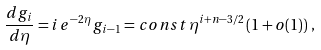Convert formula to latex. <formula><loc_0><loc_0><loc_500><loc_500>\frac { d g _ { i } } { d \eta } = i \, e ^ { - 2 \eta } \, g _ { i - 1 } = c o n s t \, \eta ^ { i + n - 3 / 2 } \left ( 1 + o ( 1 ) \right ) \, ,</formula> 